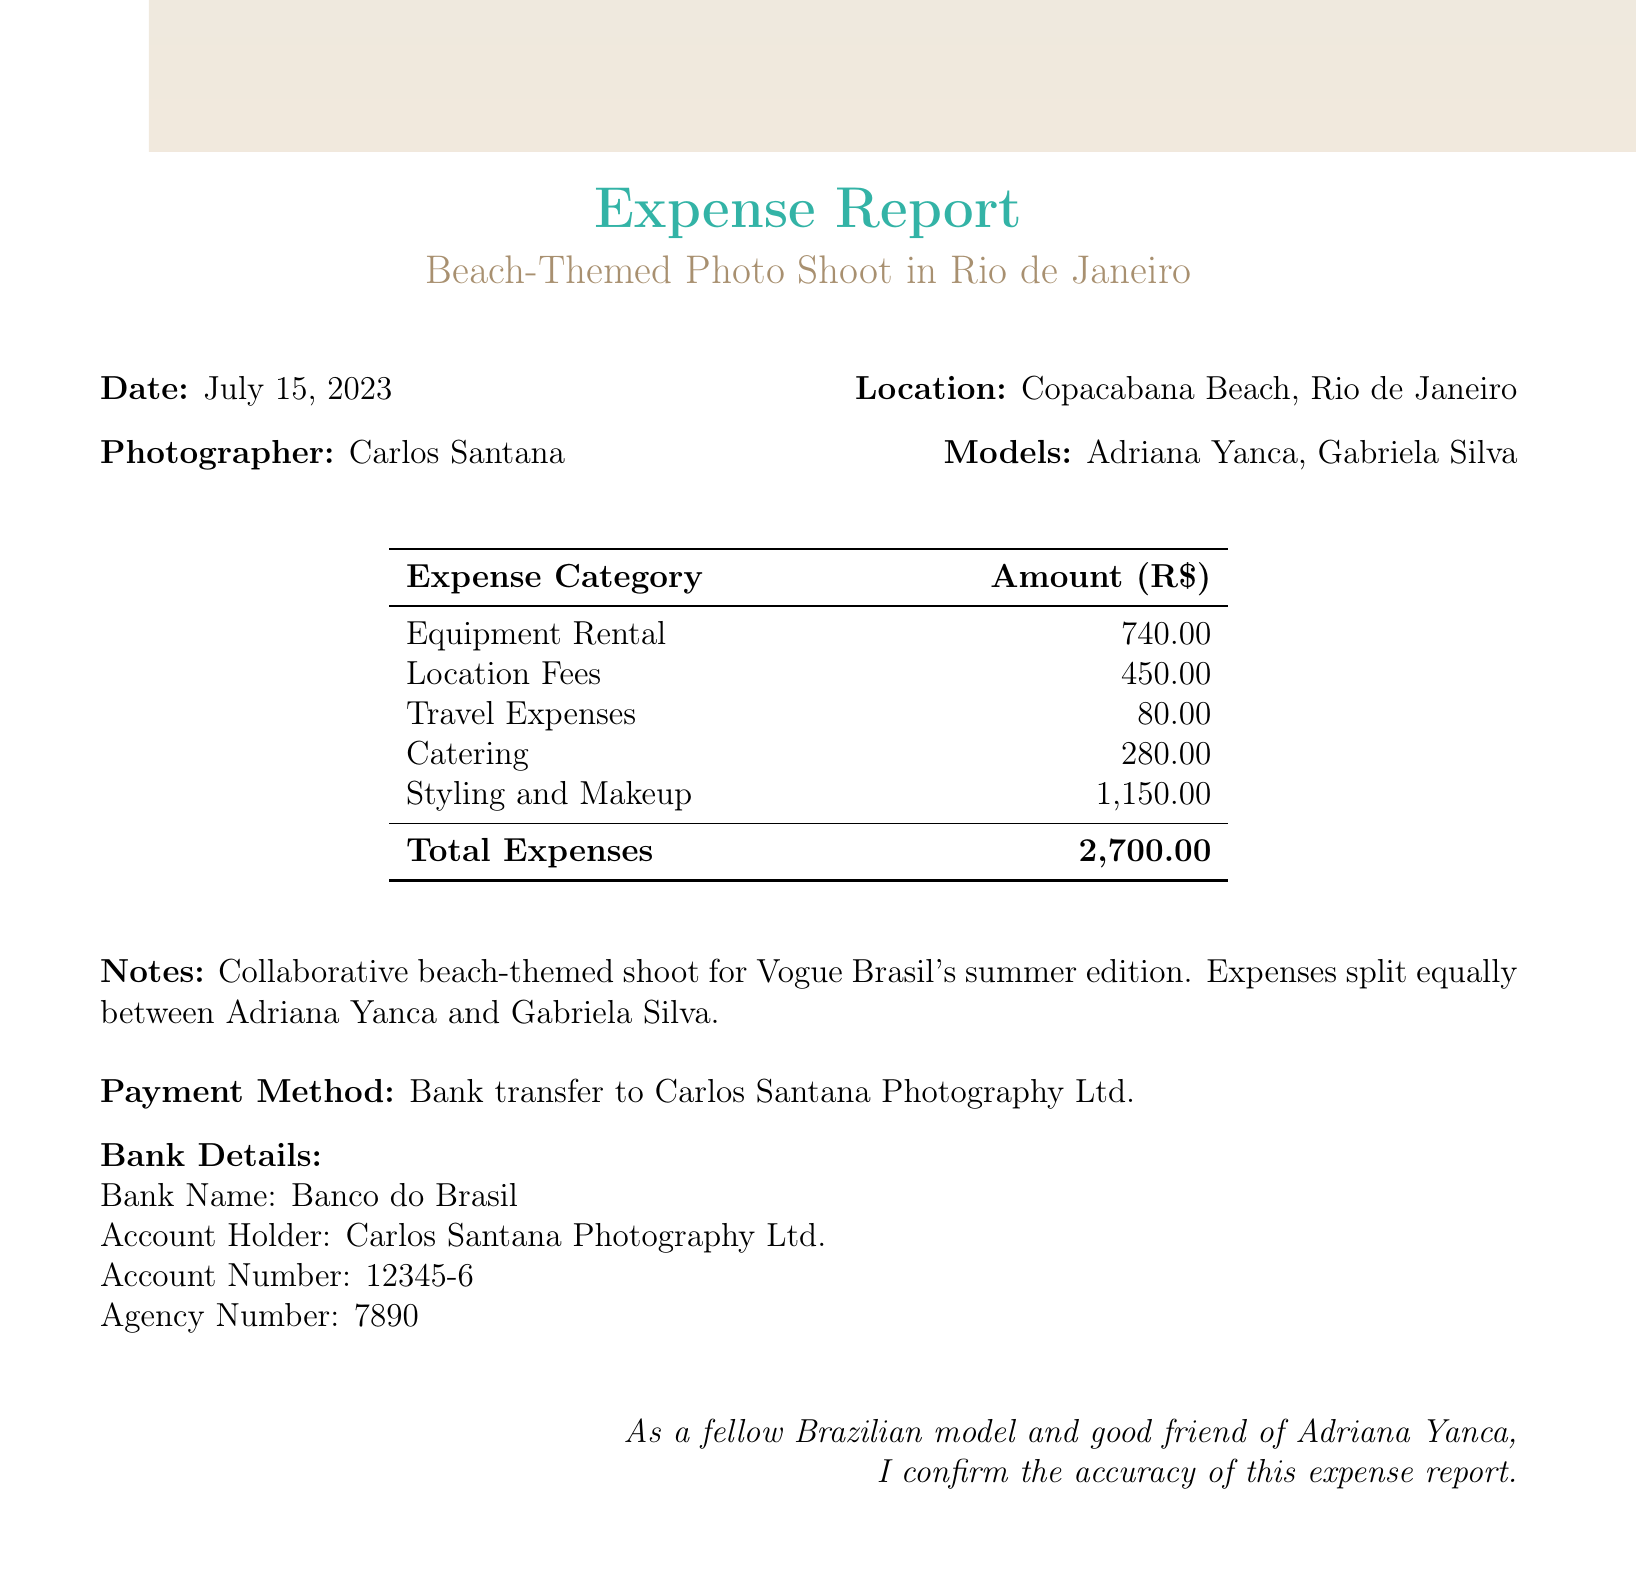what is the date of the photo shoot? The date of the photo shoot is explicitly stated in the document.
Answer: July 15, 2023 who is the photographer? The photographer's name is mentioned in the document.
Answer: Carlos Santana how many models participated in the shoot? The document lists the names of the models involved in the project.
Answer: 2 what is the total expense for the photo shoot? The total expenses are summarized in the expense report section of the document.
Answer: 2,700.00 what is the cost of the Canon EOS R5 Camera rental? The cost details for equipment rental are provided in the expense report.
Answer: 500 how much did catering for the shoot cost? The total for catering expenses is detailed in the expense report.
Answer: 280.00 who are the makeup and hair stylists mentioned? The document lists specific professionals for styling and makeup services.
Answer: Luiza Fernandes and Ricardo Oliveira what was the location for the shoot? The shoot location is clearly stated in the document.
Answer: Copacabana Beach, Rio de Janeiro what payment method was used for expenses? The method of payment is specified towards the end of the document.
Answer: Bank transfer to Carlos Santana Photography Ltd 